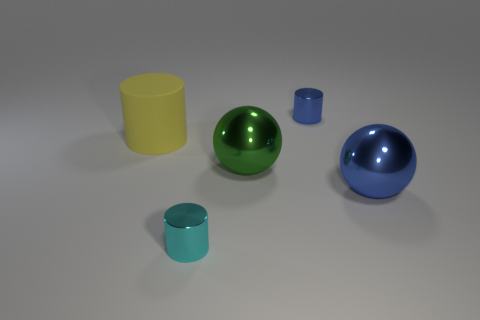Are there more small blue objects behind the large green metallic object than yellow things that are left of the yellow cylinder?
Your response must be concise. Yes. There is a green object; what shape is it?
Make the answer very short. Sphere. Are the small cylinder that is on the left side of the big green sphere and the blue thing that is in front of the yellow cylinder made of the same material?
Ensure brevity in your answer.  Yes. What shape is the large object that is left of the cyan cylinder?
Ensure brevity in your answer.  Cylinder. There is a cyan shiny thing that is the same shape as the big rubber thing; what is its size?
Make the answer very short. Small. There is a metal cylinder that is in front of the blue cylinder; is there a tiny metallic cylinder behind it?
Provide a short and direct response. Yes. The other metal thing that is the same shape as the large green object is what color?
Provide a short and direct response. Blue. What color is the small shiny thing that is to the right of the tiny thing that is in front of the small metallic cylinder that is behind the big blue sphere?
Your response must be concise. Blue. Do the blue cylinder and the small cyan cylinder have the same material?
Provide a short and direct response. Yes. Do the green object and the big yellow matte thing have the same shape?
Ensure brevity in your answer.  No. 